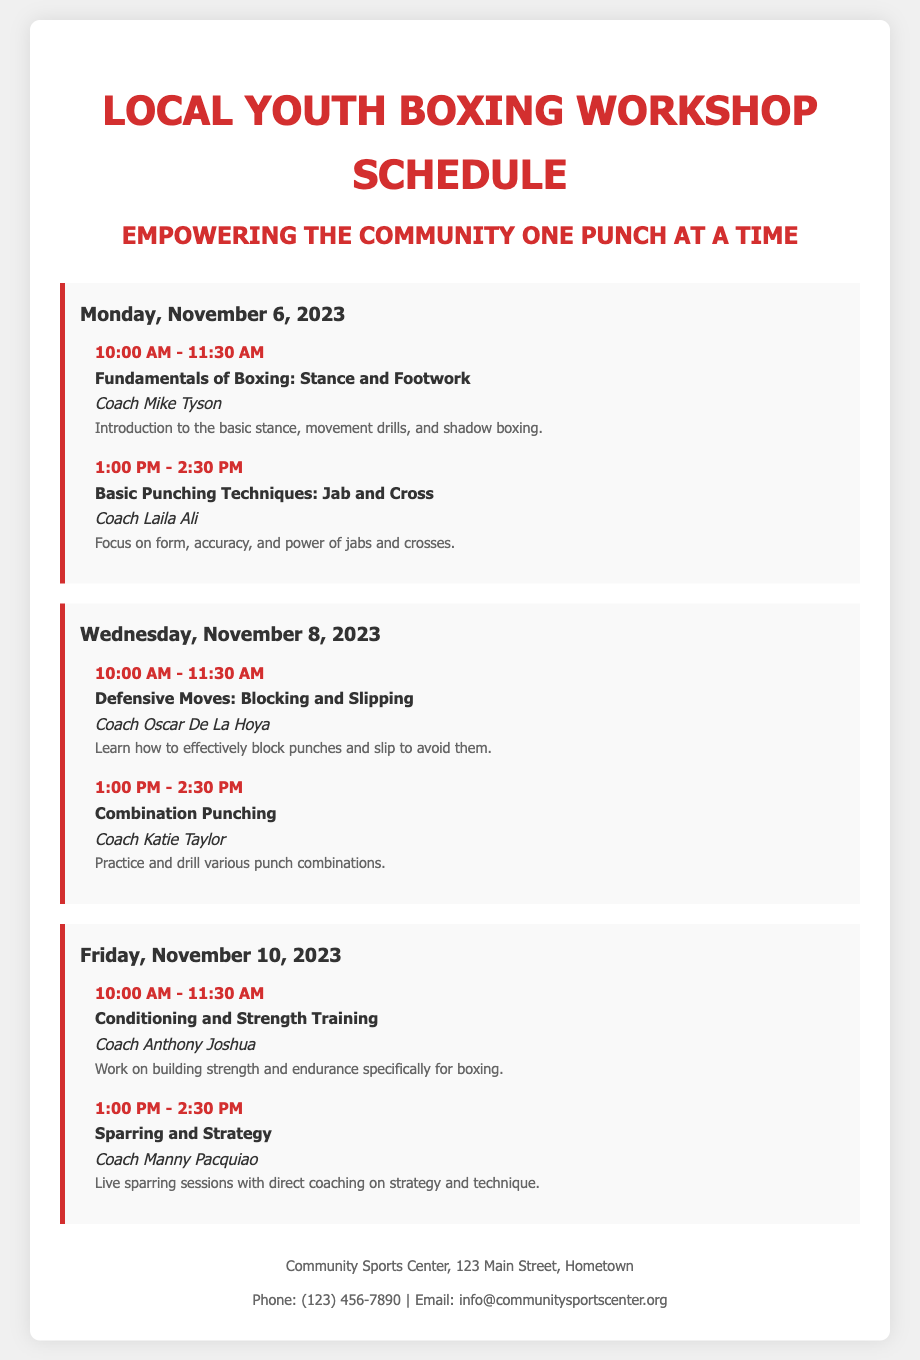What is the title of the document? The title of the document is displayed prominently at the top of the rendered page.
Answer: Local Youth Boxing Workshop Schedule Who is the trainer for the session on Fundamentals of Boxing? This relevant detail is found in the session description for the first workshop on Monday.
Answer: Coach Mike Tyson What is the duration of each session? The usual time slots for the sessions indicate their duration is consistent throughout the schedule.
Answer: 1.5 hours On which date is the Conditioning and Strength Training session held? The date for this specific session can be found under the Friday schedule.
Answer: November 10, 2023 Which coach is assigned to the Combination Punching session? The name of the trainer for this session is mentioned in the Wednesday schedule section.
Answer: Coach Katie Taylor What is the topic of the final session on November 10? The document lists session topics, allowing us to identify the theme of the last workshop.
Answer: Sparring and Strategy How many sessions are scheduled on each day? The number of sessions can be counted for each day listed in the document.
Answer: 2 sessions What is the contact email for the Community Sports Center? The footer of the document provides the contact information, including an email address.
Answer: info@communitysportscenter.org 